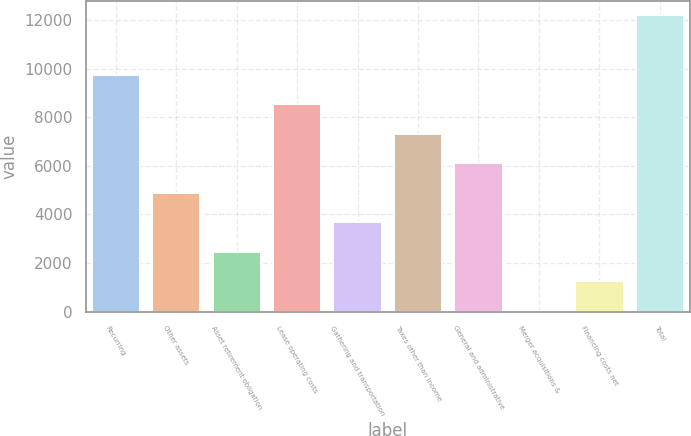<chart> <loc_0><loc_0><loc_500><loc_500><bar_chart><fcel>Recurring<fcel>Other assets<fcel>Asset retirement obligation<fcel>Lease operating costs<fcel>Gathering and transportation<fcel>Taxes other than income<fcel>General and administrative<fcel>Merger acquisitions &<fcel>Financing costs net<fcel>Total<nl><fcel>9767<fcel>4899<fcel>2465<fcel>8550<fcel>3682<fcel>7333<fcel>6116<fcel>31<fcel>1248<fcel>12201<nl></chart> 